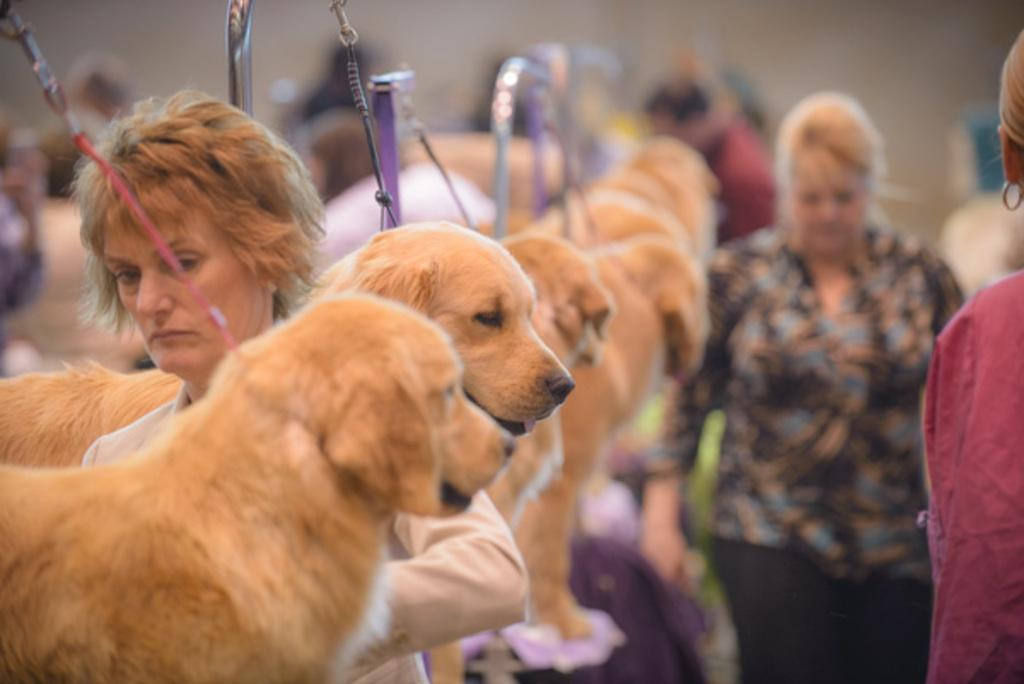Who or what can be seen in the image? There are people and dogs in the image. What else is present in the image besides people and dogs? There are wires and poles in the image. Can you describe the background of the image? The background of the image is blurred. What type of wool is being used to make the bead in the image? There is no wool or bead present in the image. 